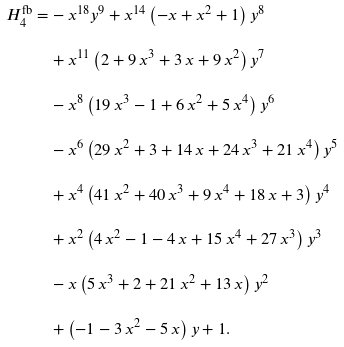Convert formula to latex. <formula><loc_0><loc_0><loc_500><loc_500>H _ { 4 } ^ { \text {fb} } = & - { x } ^ { 1 8 } { y } ^ { 9 } + { x } ^ { 1 4 } \left ( - x + { x } ^ { 2 } + 1 \right ) { y } ^ { 8 } \\ & + { x } ^ { 1 1 } \left ( 2 + 9 \, { x } ^ { 3 } + 3 \, x + 9 \, { x } ^ { 2 } \right ) { y } ^ { 7 } \\ & - { x } ^ { 8 } \left ( 1 9 \, { x } ^ { 3 } - 1 + 6 \, { x } ^ { 2 } + 5 \, { x } ^ { 4 } \right ) { y } ^ { 6 } \\ & - { x } ^ { 6 } \left ( 2 9 \, { x } ^ { 2 } + 3 + 1 4 \, x + 2 4 \, { x } ^ { 3 } + 2 1 \, { x } ^ { 4 } \right ) { y } ^ { 5 } \\ & + { x } ^ { 4 } \left ( 4 1 \, { x } ^ { 2 } + 4 0 \, { x } ^ { 3 } + 9 \, { x } ^ { 4 } + 1 8 \, x + 3 \right ) { y } ^ { 4 } \\ & + { x } ^ { 2 } \left ( 4 \, { x } ^ { 2 } - 1 - 4 \, x + 1 5 \, { x } ^ { 4 } + 2 7 \, { x } ^ { 3 } \right ) { y } ^ { 3 } \\ & - x \left ( 5 \, { x } ^ { 3 } + 2 + 2 1 \, { x } ^ { 2 } + 1 3 \, x \right ) { y } ^ { 2 } \\ & + \left ( - 1 - 3 \, { x } ^ { 2 } - 5 \, x \right ) y + 1 .</formula> 